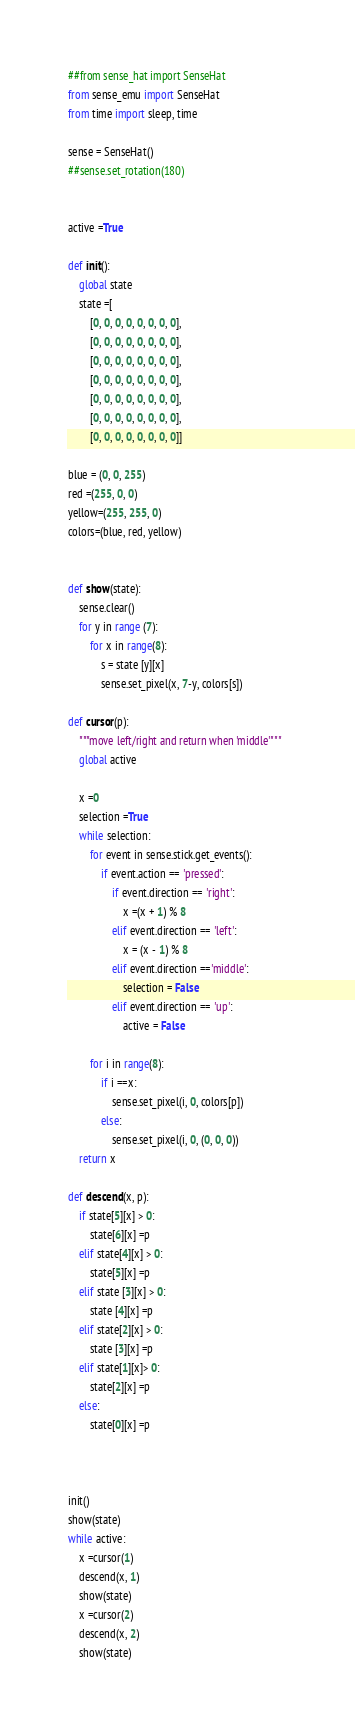Convert code to text. <code><loc_0><loc_0><loc_500><loc_500><_Python_>##from sense_hat import SenseHat
from sense_emu import SenseHat
from time import sleep, time

sense = SenseHat()
##sense.set_rotation(180)


active =True

def init():
    global state
    state =[
        [0, 0, 0, 0, 0, 0, 0, 0], 
        [0, 0, 0, 0, 0, 0, 0, 0], 
        [0, 0, 0, 0, 0, 0, 0, 0], 
        [0, 0, 0, 0, 0, 0, 0, 0], 
        [0, 0, 0, 0, 0, 0, 0, 0], 
        [0, 0, 0, 0, 0, 0, 0, 0], 
        [0, 0, 0, 0, 0, 0, 0, 0]]
    
blue = (0, 0, 255)
red =(255, 0, 0)
yellow=(255, 255, 0)
colors=(blue, red, yellow)


def show(state):
    sense.clear()
    for y in range (7):
        for x in range(8):
            s = state [y][x]
            sense.set_pixel(x, 7-y, colors[s])
        
def cursor(p):
    """move left/right and return when 'middle'"""
    global active
    
    x =0
    selection =True
    while selection:
        for event in sense.stick.get_events():
            if event.action == 'pressed':
                if event.direction == 'right':
                    x =(x + 1) % 8
                elif event.direction == 'left':
                    x = (x - 1) % 8 
                elif event.direction =='middle':
                    selection = False
                elif event.direction == 'up':
                    active = False
                    
        for i in range(8):
            if i ==x:
                sense.set_pixel(i, 0, colors[p])                
            else:    
                sense.set_pixel(i, 0, (0, 0, 0))
    return x                                

def descend(x, p):
    if state[5][x] > 0: 
        state[6][x] =p
    elif state[4][x] > 0: 
        state[5][x] =p
    elif state [3][x] > 0:
        state [4][x] =p
    elif state[2][x] > 0:
        state [3][x] =p
    elif state[1][x]> 0:
        state[2][x] =p
    else:
        state[0][x] =p
        
    

init()
show(state)
while active:
    x =cursor(1)
    descend(x, 1)
    show(state)
    x =cursor(2)
    descend(x, 2)
    show(state)   </code> 